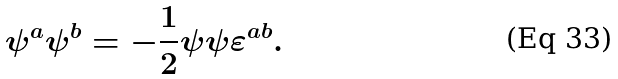Convert formula to latex. <formula><loc_0><loc_0><loc_500><loc_500>\psi ^ { a } \psi ^ { b } = - \frac { 1 } { 2 } \psi \psi \varepsilon ^ { a b } .</formula> 